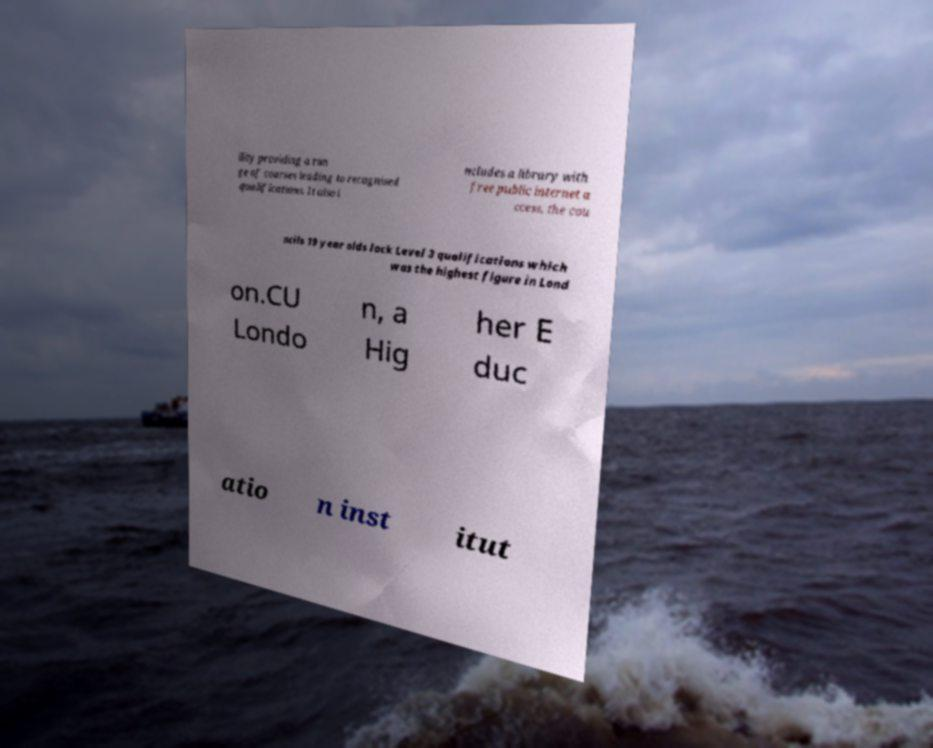Could you assist in decoding the text presented in this image and type it out clearly? ility providing a ran ge of courses leading to recognised qualifications. It also i ncludes a library with free public internet a ccess, the cou ncils 19 year olds lack Level 3 qualifications which was the highest figure in Lond on.CU Londo n, a Hig her E duc atio n inst itut 